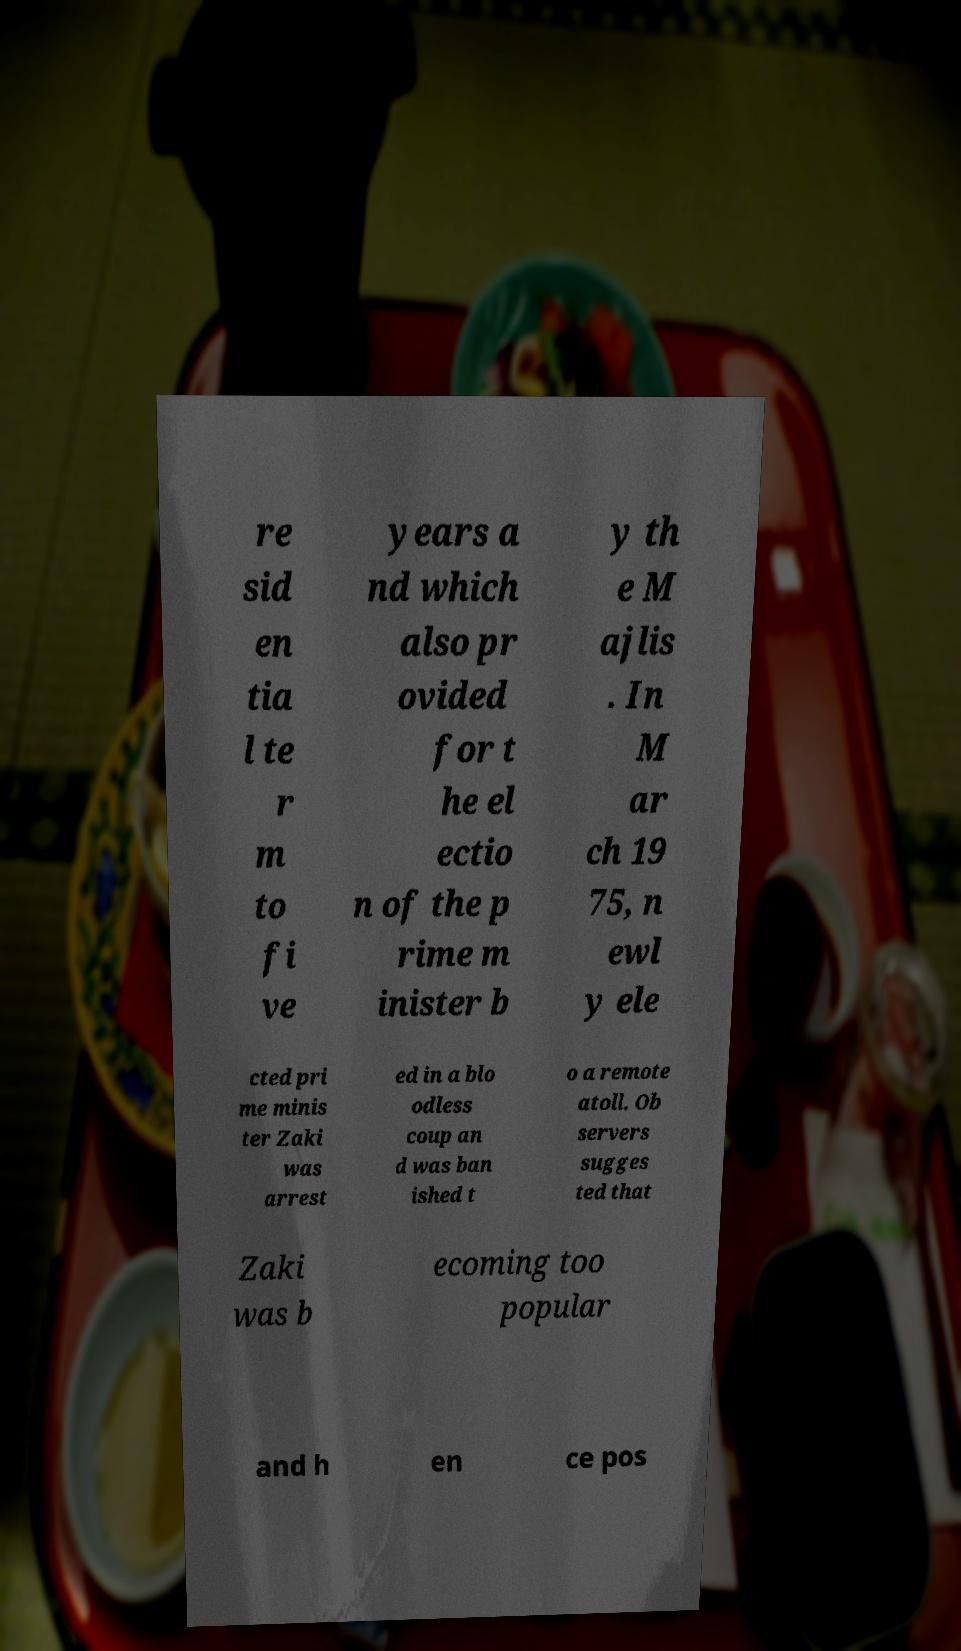What messages or text are displayed in this image? I need them in a readable, typed format. re sid en tia l te r m to fi ve years a nd which also pr ovided for t he el ectio n of the p rime m inister b y th e M ajlis . In M ar ch 19 75, n ewl y ele cted pri me minis ter Zaki was arrest ed in a blo odless coup an d was ban ished t o a remote atoll. Ob servers sugges ted that Zaki was b ecoming too popular and h en ce pos 